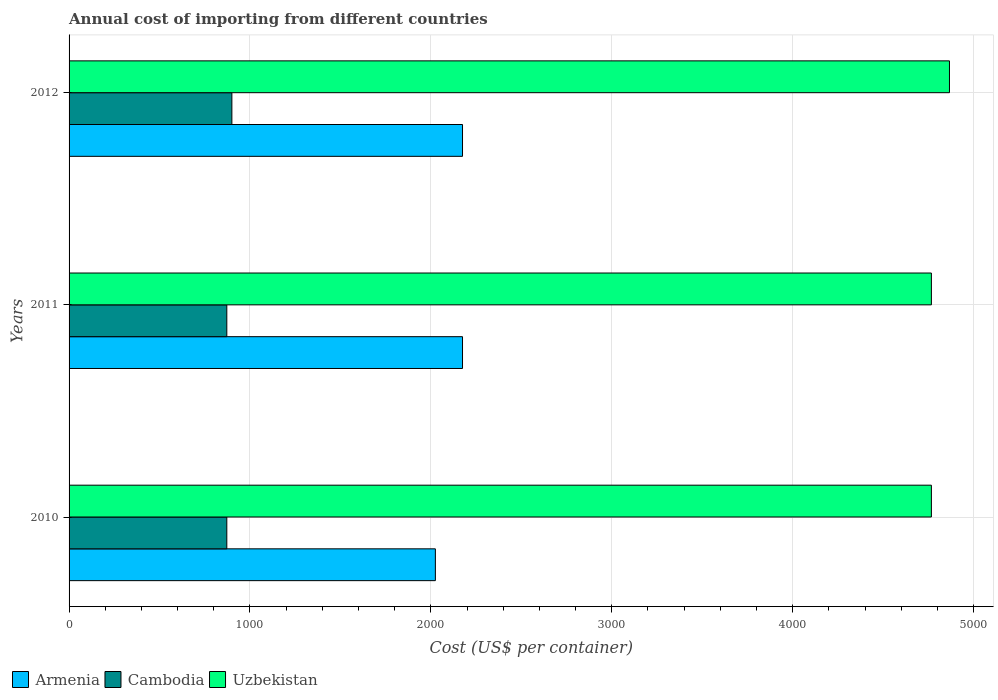How many groups of bars are there?
Offer a very short reply. 3. Are the number of bars on each tick of the Y-axis equal?
Ensure brevity in your answer.  Yes. How many bars are there on the 1st tick from the top?
Offer a terse response. 3. What is the total annual cost of importing in Uzbekistan in 2010?
Provide a short and direct response. 4767. Across all years, what is the maximum total annual cost of importing in Armenia?
Offer a very short reply. 2175. Across all years, what is the minimum total annual cost of importing in Uzbekistan?
Offer a terse response. 4767. In which year was the total annual cost of importing in Armenia maximum?
Keep it short and to the point. 2011. In which year was the total annual cost of importing in Uzbekistan minimum?
Make the answer very short. 2010. What is the total total annual cost of importing in Uzbekistan in the graph?
Keep it short and to the point. 1.44e+04. What is the difference between the total annual cost of importing in Uzbekistan in 2010 and that in 2012?
Your answer should be very brief. -100. What is the difference between the total annual cost of importing in Cambodia in 2010 and the total annual cost of importing in Uzbekistan in 2011?
Your answer should be very brief. -3895. What is the average total annual cost of importing in Cambodia per year?
Provide a succinct answer. 881.33. In the year 2011, what is the difference between the total annual cost of importing in Uzbekistan and total annual cost of importing in Cambodia?
Keep it short and to the point. 3895. What is the ratio of the total annual cost of importing in Armenia in 2010 to that in 2012?
Provide a short and direct response. 0.93. What is the difference between the highest and the second highest total annual cost of importing in Cambodia?
Make the answer very short. 28. What is the difference between the highest and the lowest total annual cost of importing in Uzbekistan?
Make the answer very short. 100. What does the 1st bar from the top in 2011 represents?
Offer a very short reply. Uzbekistan. What does the 2nd bar from the bottom in 2010 represents?
Make the answer very short. Cambodia. Are all the bars in the graph horizontal?
Offer a very short reply. Yes. How many years are there in the graph?
Offer a very short reply. 3. What is the difference between two consecutive major ticks on the X-axis?
Make the answer very short. 1000. Does the graph contain any zero values?
Provide a short and direct response. No. What is the title of the graph?
Ensure brevity in your answer.  Annual cost of importing from different countries. What is the label or title of the X-axis?
Keep it short and to the point. Cost (US$ per container). What is the label or title of the Y-axis?
Give a very brief answer. Years. What is the Cost (US$ per container) in Armenia in 2010?
Your answer should be compact. 2025. What is the Cost (US$ per container) in Cambodia in 2010?
Make the answer very short. 872. What is the Cost (US$ per container) in Uzbekistan in 2010?
Make the answer very short. 4767. What is the Cost (US$ per container) in Armenia in 2011?
Your response must be concise. 2175. What is the Cost (US$ per container) in Cambodia in 2011?
Keep it short and to the point. 872. What is the Cost (US$ per container) of Uzbekistan in 2011?
Your answer should be compact. 4767. What is the Cost (US$ per container) in Armenia in 2012?
Offer a terse response. 2175. What is the Cost (US$ per container) in Cambodia in 2012?
Ensure brevity in your answer.  900. What is the Cost (US$ per container) of Uzbekistan in 2012?
Your response must be concise. 4867. Across all years, what is the maximum Cost (US$ per container) of Armenia?
Your answer should be compact. 2175. Across all years, what is the maximum Cost (US$ per container) in Cambodia?
Offer a very short reply. 900. Across all years, what is the maximum Cost (US$ per container) of Uzbekistan?
Ensure brevity in your answer.  4867. Across all years, what is the minimum Cost (US$ per container) of Armenia?
Give a very brief answer. 2025. Across all years, what is the minimum Cost (US$ per container) of Cambodia?
Provide a short and direct response. 872. Across all years, what is the minimum Cost (US$ per container) in Uzbekistan?
Ensure brevity in your answer.  4767. What is the total Cost (US$ per container) in Armenia in the graph?
Offer a terse response. 6375. What is the total Cost (US$ per container) in Cambodia in the graph?
Provide a short and direct response. 2644. What is the total Cost (US$ per container) of Uzbekistan in the graph?
Provide a short and direct response. 1.44e+04. What is the difference between the Cost (US$ per container) in Armenia in 2010 and that in 2011?
Provide a short and direct response. -150. What is the difference between the Cost (US$ per container) of Cambodia in 2010 and that in 2011?
Provide a succinct answer. 0. What is the difference between the Cost (US$ per container) in Uzbekistan in 2010 and that in 2011?
Provide a succinct answer. 0. What is the difference between the Cost (US$ per container) of Armenia in 2010 and that in 2012?
Give a very brief answer. -150. What is the difference between the Cost (US$ per container) of Cambodia in 2010 and that in 2012?
Provide a succinct answer. -28. What is the difference between the Cost (US$ per container) of Uzbekistan in 2010 and that in 2012?
Give a very brief answer. -100. What is the difference between the Cost (US$ per container) of Armenia in 2011 and that in 2012?
Offer a very short reply. 0. What is the difference between the Cost (US$ per container) in Cambodia in 2011 and that in 2012?
Make the answer very short. -28. What is the difference between the Cost (US$ per container) in Uzbekistan in 2011 and that in 2012?
Your response must be concise. -100. What is the difference between the Cost (US$ per container) in Armenia in 2010 and the Cost (US$ per container) in Cambodia in 2011?
Offer a terse response. 1153. What is the difference between the Cost (US$ per container) of Armenia in 2010 and the Cost (US$ per container) of Uzbekistan in 2011?
Provide a short and direct response. -2742. What is the difference between the Cost (US$ per container) in Cambodia in 2010 and the Cost (US$ per container) in Uzbekistan in 2011?
Provide a succinct answer. -3895. What is the difference between the Cost (US$ per container) of Armenia in 2010 and the Cost (US$ per container) of Cambodia in 2012?
Keep it short and to the point. 1125. What is the difference between the Cost (US$ per container) in Armenia in 2010 and the Cost (US$ per container) in Uzbekistan in 2012?
Offer a terse response. -2842. What is the difference between the Cost (US$ per container) in Cambodia in 2010 and the Cost (US$ per container) in Uzbekistan in 2012?
Ensure brevity in your answer.  -3995. What is the difference between the Cost (US$ per container) of Armenia in 2011 and the Cost (US$ per container) of Cambodia in 2012?
Offer a terse response. 1275. What is the difference between the Cost (US$ per container) of Armenia in 2011 and the Cost (US$ per container) of Uzbekistan in 2012?
Provide a short and direct response. -2692. What is the difference between the Cost (US$ per container) in Cambodia in 2011 and the Cost (US$ per container) in Uzbekistan in 2012?
Your answer should be very brief. -3995. What is the average Cost (US$ per container) in Armenia per year?
Your response must be concise. 2125. What is the average Cost (US$ per container) in Cambodia per year?
Your answer should be compact. 881.33. What is the average Cost (US$ per container) in Uzbekistan per year?
Keep it short and to the point. 4800.33. In the year 2010, what is the difference between the Cost (US$ per container) of Armenia and Cost (US$ per container) of Cambodia?
Provide a succinct answer. 1153. In the year 2010, what is the difference between the Cost (US$ per container) in Armenia and Cost (US$ per container) in Uzbekistan?
Provide a succinct answer. -2742. In the year 2010, what is the difference between the Cost (US$ per container) of Cambodia and Cost (US$ per container) of Uzbekistan?
Provide a short and direct response. -3895. In the year 2011, what is the difference between the Cost (US$ per container) in Armenia and Cost (US$ per container) in Cambodia?
Offer a terse response. 1303. In the year 2011, what is the difference between the Cost (US$ per container) in Armenia and Cost (US$ per container) in Uzbekistan?
Your response must be concise. -2592. In the year 2011, what is the difference between the Cost (US$ per container) of Cambodia and Cost (US$ per container) of Uzbekistan?
Your response must be concise. -3895. In the year 2012, what is the difference between the Cost (US$ per container) of Armenia and Cost (US$ per container) of Cambodia?
Offer a very short reply. 1275. In the year 2012, what is the difference between the Cost (US$ per container) of Armenia and Cost (US$ per container) of Uzbekistan?
Keep it short and to the point. -2692. In the year 2012, what is the difference between the Cost (US$ per container) of Cambodia and Cost (US$ per container) of Uzbekistan?
Your answer should be compact. -3967. What is the ratio of the Cost (US$ per container) of Cambodia in 2010 to that in 2011?
Give a very brief answer. 1. What is the ratio of the Cost (US$ per container) in Armenia in 2010 to that in 2012?
Offer a terse response. 0.93. What is the ratio of the Cost (US$ per container) of Cambodia in 2010 to that in 2012?
Offer a very short reply. 0.97. What is the ratio of the Cost (US$ per container) of Uzbekistan in 2010 to that in 2012?
Provide a short and direct response. 0.98. What is the ratio of the Cost (US$ per container) in Armenia in 2011 to that in 2012?
Provide a succinct answer. 1. What is the ratio of the Cost (US$ per container) in Cambodia in 2011 to that in 2012?
Give a very brief answer. 0.97. What is the ratio of the Cost (US$ per container) of Uzbekistan in 2011 to that in 2012?
Provide a short and direct response. 0.98. What is the difference between the highest and the second highest Cost (US$ per container) of Armenia?
Your answer should be very brief. 0. What is the difference between the highest and the lowest Cost (US$ per container) in Armenia?
Provide a short and direct response. 150. What is the difference between the highest and the lowest Cost (US$ per container) in Cambodia?
Give a very brief answer. 28. What is the difference between the highest and the lowest Cost (US$ per container) in Uzbekistan?
Your answer should be compact. 100. 